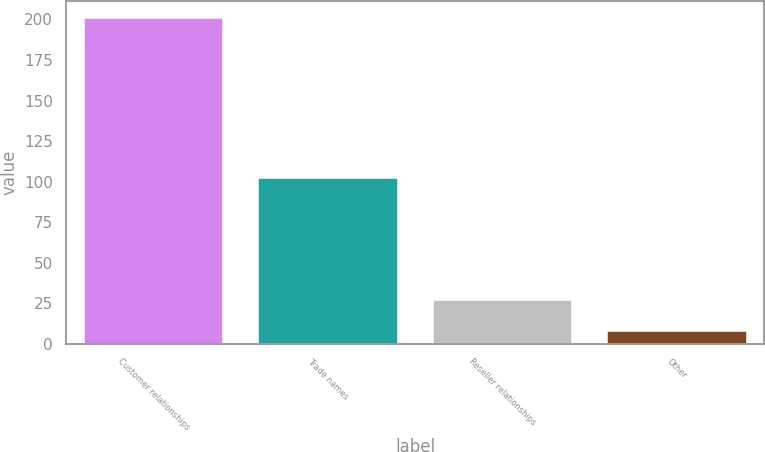Convert chart to OTSL. <chart><loc_0><loc_0><loc_500><loc_500><bar_chart><fcel>Customer relationships<fcel>Trade names<fcel>Reseller relationships<fcel>Other<nl><fcel>201<fcel>102<fcel>27.3<fcel>8<nl></chart> 